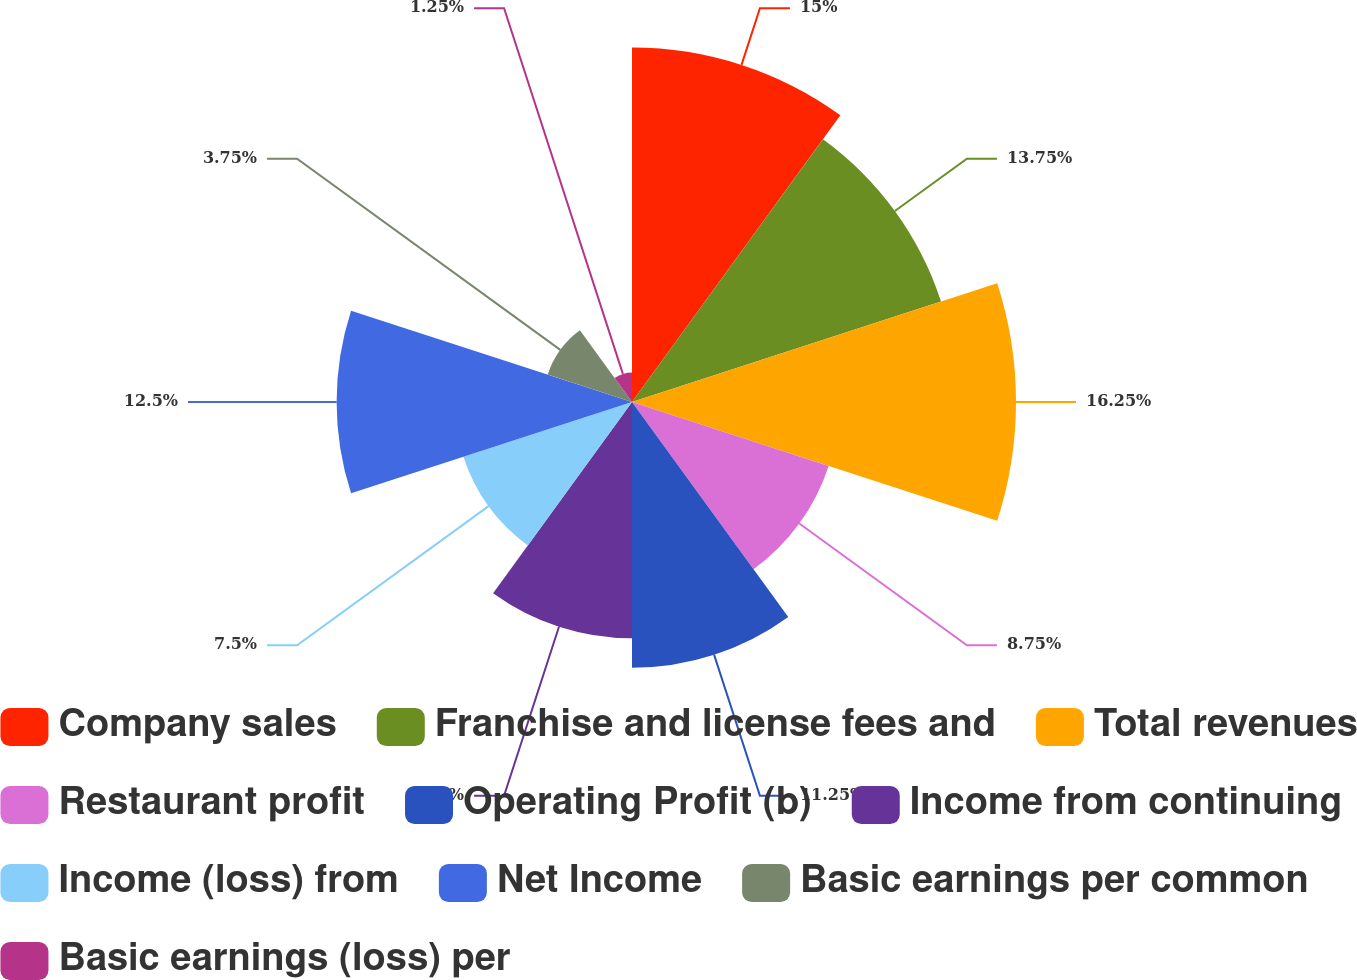Convert chart. <chart><loc_0><loc_0><loc_500><loc_500><pie_chart><fcel>Company sales<fcel>Franchise and license fees and<fcel>Total revenues<fcel>Restaurant profit<fcel>Operating Profit (b)<fcel>Income from continuing<fcel>Income (loss) from<fcel>Net Income<fcel>Basic earnings per common<fcel>Basic earnings (loss) per<nl><fcel>15.0%<fcel>13.75%<fcel>16.25%<fcel>8.75%<fcel>11.25%<fcel>10.0%<fcel>7.5%<fcel>12.5%<fcel>3.75%<fcel>1.25%<nl></chart> 